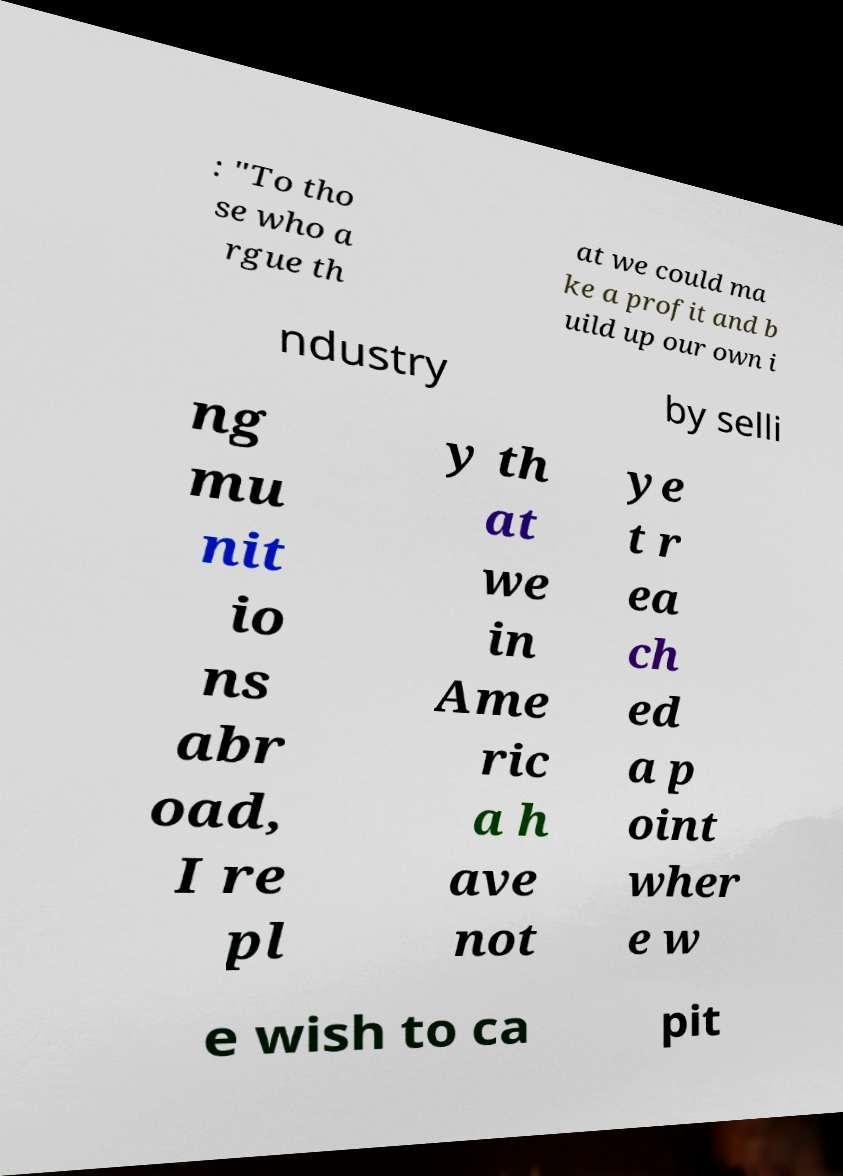Could you extract and type out the text from this image? : "To tho se who a rgue th at we could ma ke a profit and b uild up our own i ndustry by selli ng mu nit io ns abr oad, I re pl y th at we in Ame ric a h ave not ye t r ea ch ed a p oint wher e w e wish to ca pit 